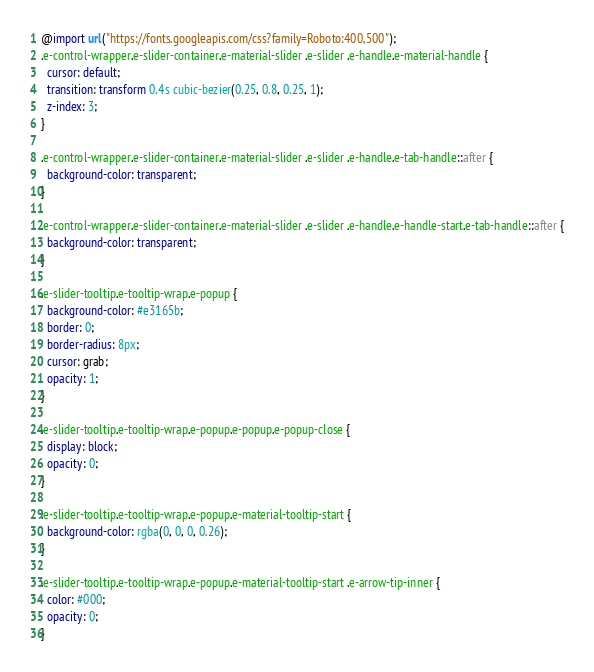<code> <loc_0><loc_0><loc_500><loc_500><_CSS_>@import url("https://fonts.googleapis.com/css?family=Roboto:400,500");
.e-control-wrapper.e-slider-container.e-material-slider .e-slider .e-handle.e-material-handle {
  cursor: default;
  transition: transform 0.4s cubic-bezier(0.25, 0.8, 0.25, 1);
  z-index: 3;
}

.e-control-wrapper.e-slider-container.e-material-slider .e-slider .e-handle.e-tab-handle::after {
  background-color: transparent;
}

.e-control-wrapper.e-slider-container.e-material-slider .e-slider .e-handle.e-handle-start.e-tab-handle::after {
  background-color: transparent;
}

.e-slider-tooltip.e-tooltip-wrap.e-popup {
  background-color: #e3165b;
  border: 0;
  border-radius: 8px;
  cursor: grab;
  opacity: 1;
}

.e-slider-tooltip.e-tooltip-wrap.e-popup.e-popup.e-popup-close {
  display: block;
  opacity: 0;
}

.e-slider-tooltip.e-tooltip-wrap.e-popup.e-material-tooltip-start {
  background-color: rgba(0, 0, 0, 0.26);
}

.e-slider-tooltip.e-tooltip-wrap.e-popup.e-material-tooltip-start .e-arrow-tip-inner {
  color: #000;
  opacity: 0;
}
</code> 